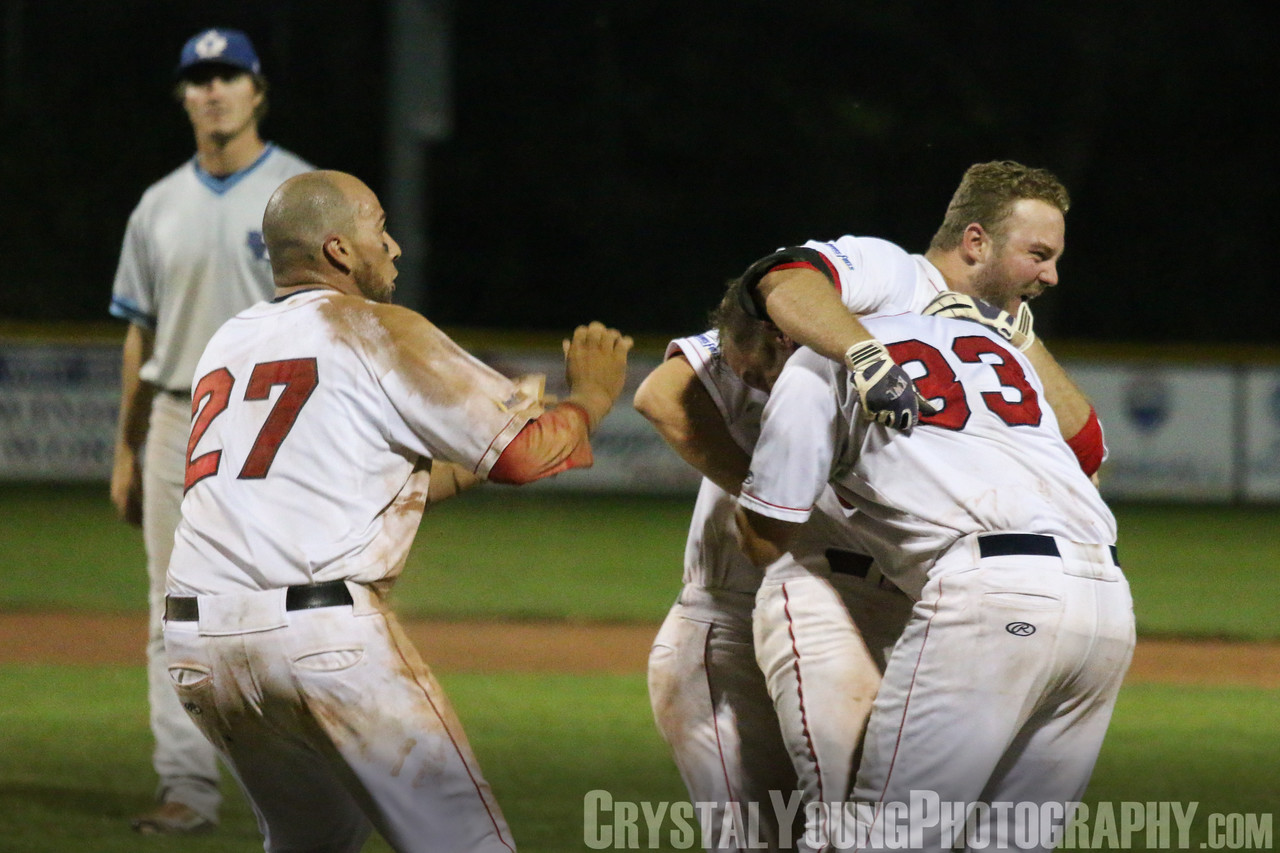Describe an alternative scenario where the celebration is for a different reason than winning the game. An alternative scenario might be that the players are celebrating a teammate reaching a significant career milestone, such as hitting a 500th career home run or breaking a long-standing record. The sheer excitement and collective joy reflect their deep respect and admiration for their teammate's achievement. The embrace and jubilant reactions signify not just a celebration of the milestone, but also the recognition of the hard work and dedication that led up to this moment. In this context, the solitary player in the background might be contemplating his own goals and aspirations, reflecting on the journey that lies ahead for him. 